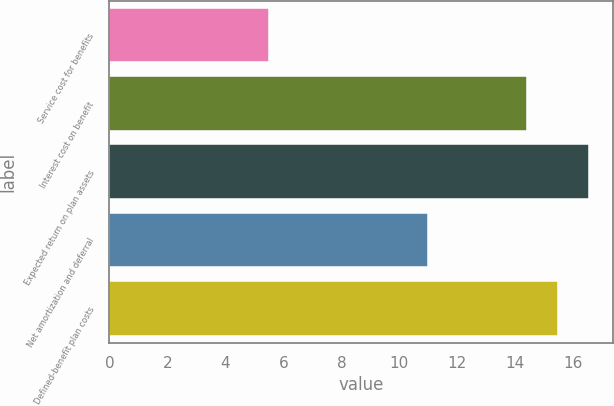Convert chart to OTSL. <chart><loc_0><loc_0><loc_500><loc_500><bar_chart><fcel>Service cost for benefits<fcel>Interest cost on benefit<fcel>Expected return on plan assets<fcel>Net amortization and deferral<fcel>Defined-benefit plan costs<nl><fcel>5.5<fcel>14.4<fcel>16.56<fcel>11<fcel>15.48<nl></chart> 